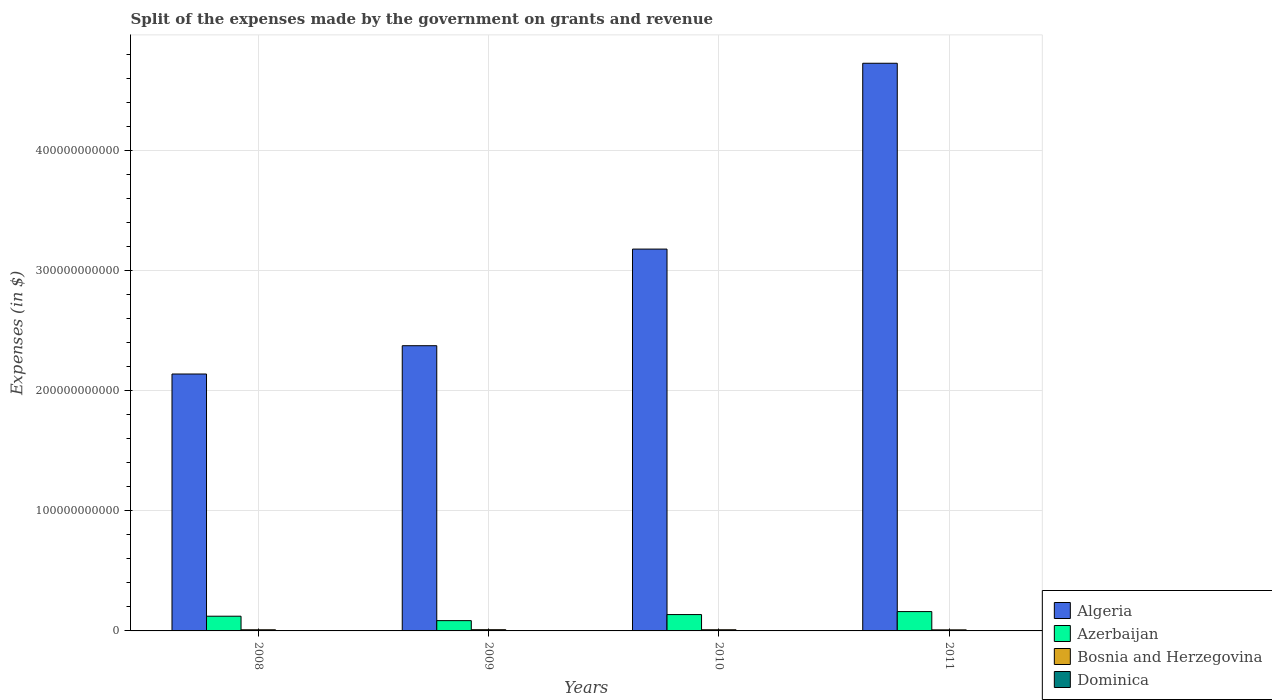How many different coloured bars are there?
Offer a terse response. 4. How many groups of bars are there?
Give a very brief answer. 4. Are the number of bars per tick equal to the number of legend labels?
Provide a short and direct response. Yes. Are the number of bars on each tick of the X-axis equal?
Offer a very short reply. Yes. In how many cases, is the number of bars for a given year not equal to the number of legend labels?
Provide a short and direct response. 0. What is the expenses made by the government on grants and revenue in Azerbaijan in 2010?
Ensure brevity in your answer.  1.36e+1. Across all years, what is the maximum expenses made by the government on grants and revenue in Bosnia and Herzegovina?
Your response must be concise. 1.02e+09. Across all years, what is the minimum expenses made by the government on grants and revenue in Azerbaijan?
Your answer should be very brief. 8.57e+09. What is the total expenses made by the government on grants and revenue in Algeria in the graph?
Keep it short and to the point. 1.24e+12. What is the difference between the expenses made by the government on grants and revenue in Azerbaijan in 2010 and that in 2011?
Your response must be concise. -2.48e+09. What is the difference between the expenses made by the government on grants and revenue in Algeria in 2008 and the expenses made by the government on grants and revenue in Azerbaijan in 2009?
Your answer should be very brief. 2.05e+11. What is the average expenses made by the government on grants and revenue in Bosnia and Herzegovina per year?
Give a very brief answer. 9.57e+08. In the year 2009, what is the difference between the expenses made by the government on grants and revenue in Algeria and expenses made by the government on grants and revenue in Azerbaijan?
Keep it short and to the point. 2.29e+11. What is the ratio of the expenses made by the government on grants and revenue in Azerbaijan in 2009 to that in 2010?
Your response must be concise. 0.63. Is the expenses made by the government on grants and revenue in Dominica in 2008 less than that in 2011?
Provide a short and direct response. No. What is the difference between the highest and the second highest expenses made by the government on grants and revenue in Dominica?
Your response must be concise. 1.74e+07. What is the difference between the highest and the lowest expenses made by the government on grants and revenue in Azerbaijan?
Offer a very short reply. 7.53e+09. Is the sum of the expenses made by the government on grants and revenue in Bosnia and Herzegovina in 2010 and 2011 greater than the maximum expenses made by the government on grants and revenue in Azerbaijan across all years?
Your answer should be compact. No. Is it the case that in every year, the sum of the expenses made by the government on grants and revenue in Dominica and expenses made by the government on grants and revenue in Azerbaijan is greater than the sum of expenses made by the government on grants and revenue in Algeria and expenses made by the government on grants and revenue in Bosnia and Herzegovina?
Provide a succinct answer. No. What does the 4th bar from the left in 2010 represents?
Provide a succinct answer. Dominica. What does the 4th bar from the right in 2010 represents?
Your answer should be compact. Algeria. Is it the case that in every year, the sum of the expenses made by the government on grants and revenue in Bosnia and Herzegovina and expenses made by the government on grants and revenue in Algeria is greater than the expenses made by the government on grants and revenue in Azerbaijan?
Your answer should be compact. Yes. What is the difference between two consecutive major ticks on the Y-axis?
Offer a terse response. 1.00e+11. Does the graph contain any zero values?
Provide a succinct answer. No. How many legend labels are there?
Your answer should be compact. 4. How are the legend labels stacked?
Keep it short and to the point. Vertical. What is the title of the graph?
Offer a terse response. Split of the expenses made by the government on grants and revenue. What is the label or title of the Y-axis?
Provide a succinct answer. Expenses (in $). What is the Expenses (in $) in Algeria in 2008?
Your answer should be compact. 2.14e+11. What is the Expenses (in $) in Azerbaijan in 2008?
Provide a succinct answer. 1.22e+1. What is the Expenses (in $) in Bosnia and Herzegovina in 2008?
Your answer should be very brief. 9.49e+08. What is the Expenses (in $) in Dominica in 2008?
Your response must be concise. 1.09e+08. What is the Expenses (in $) of Algeria in 2009?
Your answer should be compact. 2.37e+11. What is the Expenses (in $) in Azerbaijan in 2009?
Offer a very short reply. 8.57e+09. What is the Expenses (in $) of Bosnia and Herzegovina in 2009?
Offer a terse response. 1.02e+09. What is the Expenses (in $) of Dominica in 2009?
Give a very brief answer. 9.12e+07. What is the Expenses (in $) of Algeria in 2010?
Offer a very short reply. 3.18e+11. What is the Expenses (in $) in Azerbaijan in 2010?
Your answer should be very brief. 1.36e+1. What is the Expenses (in $) in Bosnia and Herzegovina in 2010?
Keep it short and to the point. 9.70e+08. What is the Expenses (in $) in Dominica in 2010?
Your answer should be very brief. 6.28e+07. What is the Expenses (in $) in Algeria in 2011?
Ensure brevity in your answer.  4.73e+11. What is the Expenses (in $) of Azerbaijan in 2011?
Provide a short and direct response. 1.61e+1. What is the Expenses (in $) in Bosnia and Herzegovina in 2011?
Your answer should be very brief. 8.87e+08. What is the Expenses (in $) of Dominica in 2011?
Make the answer very short. 7.71e+07. Across all years, what is the maximum Expenses (in $) in Algeria?
Give a very brief answer. 4.73e+11. Across all years, what is the maximum Expenses (in $) in Azerbaijan?
Your response must be concise. 1.61e+1. Across all years, what is the maximum Expenses (in $) in Bosnia and Herzegovina?
Offer a very short reply. 1.02e+09. Across all years, what is the maximum Expenses (in $) of Dominica?
Make the answer very short. 1.09e+08. Across all years, what is the minimum Expenses (in $) of Algeria?
Give a very brief answer. 2.14e+11. Across all years, what is the minimum Expenses (in $) of Azerbaijan?
Offer a very short reply. 8.57e+09. Across all years, what is the minimum Expenses (in $) of Bosnia and Herzegovina?
Ensure brevity in your answer.  8.87e+08. Across all years, what is the minimum Expenses (in $) in Dominica?
Offer a very short reply. 6.28e+07. What is the total Expenses (in $) of Algeria in the graph?
Offer a terse response. 1.24e+12. What is the total Expenses (in $) of Azerbaijan in the graph?
Keep it short and to the point. 5.05e+1. What is the total Expenses (in $) in Bosnia and Herzegovina in the graph?
Keep it short and to the point. 3.83e+09. What is the total Expenses (in $) in Dominica in the graph?
Provide a succinct answer. 3.40e+08. What is the difference between the Expenses (in $) of Algeria in 2008 and that in 2009?
Your response must be concise. -2.36e+1. What is the difference between the Expenses (in $) of Azerbaijan in 2008 and that in 2009?
Your answer should be compact. 3.67e+09. What is the difference between the Expenses (in $) in Bosnia and Herzegovina in 2008 and that in 2009?
Ensure brevity in your answer.  -7.27e+07. What is the difference between the Expenses (in $) in Dominica in 2008 and that in 2009?
Your response must be concise. 1.74e+07. What is the difference between the Expenses (in $) of Algeria in 2008 and that in 2010?
Make the answer very short. -1.04e+11. What is the difference between the Expenses (in $) in Azerbaijan in 2008 and that in 2010?
Provide a short and direct response. -1.37e+09. What is the difference between the Expenses (in $) in Bosnia and Herzegovina in 2008 and that in 2010?
Your answer should be very brief. -2.06e+07. What is the difference between the Expenses (in $) in Dominica in 2008 and that in 2010?
Give a very brief answer. 4.58e+07. What is the difference between the Expenses (in $) in Algeria in 2008 and that in 2011?
Provide a succinct answer. -2.59e+11. What is the difference between the Expenses (in $) in Azerbaijan in 2008 and that in 2011?
Make the answer very short. -3.86e+09. What is the difference between the Expenses (in $) in Bosnia and Herzegovina in 2008 and that in 2011?
Your answer should be compact. 6.24e+07. What is the difference between the Expenses (in $) of Dominica in 2008 and that in 2011?
Provide a succinct answer. 3.15e+07. What is the difference between the Expenses (in $) of Algeria in 2009 and that in 2010?
Ensure brevity in your answer.  -8.04e+1. What is the difference between the Expenses (in $) of Azerbaijan in 2009 and that in 2010?
Provide a short and direct response. -5.05e+09. What is the difference between the Expenses (in $) of Bosnia and Herzegovina in 2009 and that in 2010?
Give a very brief answer. 5.21e+07. What is the difference between the Expenses (in $) of Dominica in 2009 and that in 2010?
Offer a terse response. 2.84e+07. What is the difference between the Expenses (in $) in Algeria in 2009 and that in 2011?
Your response must be concise. -2.35e+11. What is the difference between the Expenses (in $) of Azerbaijan in 2009 and that in 2011?
Make the answer very short. -7.53e+09. What is the difference between the Expenses (in $) of Bosnia and Herzegovina in 2009 and that in 2011?
Ensure brevity in your answer.  1.35e+08. What is the difference between the Expenses (in $) in Dominica in 2009 and that in 2011?
Offer a terse response. 1.41e+07. What is the difference between the Expenses (in $) of Algeria in 2010 and that in 2011?
Offer a very short reply. -1.55e+11. What is the difference between the Expenses (in $) in Azerbaijan in 2010 and that in 2011?
Your answer should be very brief. -2.48e+09. What is the difference between the Expenses (in $) in Bosnia and Herzegovina in 2010 and that in 2011?
Ensure brevity in your answer.  8.30e+07. What is the difference between the Expenses (in $) of Dominica in 2010 and that in 2011?
Keep it short and to the point. -1.43e+07. What is the difference between the Expenses (in $) in Algeria in 2008 and the Expenses (in $) in Azerbaijan in 2009?
Give a very brief answer. 2.05e+11. What is the difference between the Expenses (in $) of Algeria in 2008 and the Expenses (in $) of Bosnia and Herzegovina in 2009?
Ensure brevity in your answer.  2.13e+11. What is the difference between the Expenses (in $) in Algeria in 2008 and the Expenses (in $) in Dominica in 2009?
Offer a very short reply. 2.14e+11. What is the difference between the Expenses (in $) in Azerbaijan in 2008 and the Expenses (in $) in Bosnia and Herzegovina in 2009?
Provide a short and direct response. 1.12e+1. What is the difference between the Expenses (in $) in Azerbaijan in 2008 and the Expenses (in $) in Dominica in 2009?
Your response must be concise. 1.22e+1. What is the difference between the Expenses (in $) of Bosnia and Herzegovina in 2008 and the Expenses (in $) of Dominica in 2009?
Offer a very short reply. 8.58e+08. What is the difference between the Expenses (in $) of Algeria in 2008 and the Expenses (in $) of Azerbaijan in 2010?
Provide a short and direct response. 2.00e+11. What is the difference between the Expenses (in $) in Algeria in 2008 and the Expenses (in $) in Bosnia and Herzegovina in 2010?
Provide a succinct answer. 2.13e+11. What is the difference between the Expenses (in $) in Algeria in 2008 and the Expenses (in $) in Dominica in 2010?
Give a very brief answer. 2.14e+11. What is the difference between the Expenses (in $) in Azerbaijan in 2008 and the Expenses (in $) in Bosnia and Herzegovina in 2010?
Your response must be concise. 1.13e+1. What is the difference between the Expenses (in $) of Azerbaijan in 2008 and the Expenses (in $) of Dominica in 2010?
Give a very brief answer. 1.22e+1. What is the difference between the Expenses (in $) in Bosnia and Herzegovina in 2008 and the Expenses (in $) in Dominica in 2010?
Provide a short and direct response. 8.87e+08. What is the difference between the Expenses (in $) in Algeria in 2008 and the Expenses (in $) in Azerbaijan in 2011?
Offer a very short reply. 1.98e+11. What is the difference between the Expenses (in $) of Algeria in 2008 and the Expenses (in $) of Bosnia and Herzegovina in 2011?
Your answer should be compact. 2.13e+11. What is the difference between the Expenses (in $) of Algeria in 2008 and the Expenses (in $) of Dominica in 2011?
Offer a very short reply. 2.14e+11. What is the difference between the Expenses (in $) of Azerbaijan in 2008 and the Expenses (in $) of Bosnia and Herzegovina in 2011?
Your response must be concise. 1.14e+1. What is the difference between the Expenses (in $) of Azerbaijan in 2008 and the Expenses (in $) of Dominica in 2011?
Provide a short and direct response. 1.22e+1. What is the difference between the Expenses (in $) of Bosnia and Herzegovina in 2008 and the Expenses (in $) of Dominica in 2011?
Offer a very short reply. 8.72e+08. What is the difference between the Expenses (in $) of Algeria in 2009 and the Expenses (in $) of Azerbaijan in 2010?
Your answer should be compact. 2.24e+11. What is the difference between the Expenses (in $) in Algeria in 2009 and the Expenses (in $) in Bosnia and Herzegovina in 2010?
Your answer should be compact. 2.36e+11. What is the difference between the Expenses (in $) of Algeria in 2009 and the Expenses (in $) of Dominica in 2010?
Keep it short and to the point. 2.37e+11. What is the difference between the Expenses (in $) of Azerbaijan in 2009 and the Expenses (in $) of Bosnia and Herzegovina in 2010?
Ensure brevity in your answer.  7.60e+09. What is the difference between the Expenses (in $) of Azerbaijan in 2009 and the Expenses (in $) of Dominica in 2010?
Keep it short and to the point. 8.50e+09. What is the difference between the Expenses (in $) of Bosnia and Herzegovina in 2009 and the Expenses (in $) of Dominica in 2010?
Your response must be concise. 9.59e+08. What is the difference between the Expenses (in $) in Algeria in 2009 and the Expenses (in $) in Azerbaijan in 2011?
Offer a very short reply. 2.21e+11. What is the difference between the Expenses (in $) in Algeria in 2009 and the Expenses (in $) in Bosnia and Herzegovina in 2011?
Your response must be concise. 2.37e+11. What is the difference between the Expenses (in $) in Algeria in 2009 and the Expenses (in $) in Dominica in 2011?
Offer a very short reply. 2.37e+11. What is the difference between the Expenses (in $) in Azerbaijan in 2009 and the Expenses (in $) in Bosnia and Herzegovina in 2011?
Your response must be concise. 7.68e+09. What is the difference between the Expenses (in $) in Azerbaijan in 2009 and the Expenses (in $) in Dominica in 2011?
Your response must be concise. 8.49e+09. What is the difference between the Expenses (in $) of Bosnia and Herzegovina in 2009 and the Expenses (in $) of Dominica in 2011?
Your answer should be very brief. 9.45e+08. What is the difference between the Expenses (in $) in Algeria in 2010 and the Expenses (in $) in Azerbaijan in 2011?
Keep it short and to the point. 3.02e+11. What is the difference between the Expenses (in $) of Algeria in 2010 and the Expenses (in $) of Bosnia and Herzegovina in 2011?
Ensure brevity in your answer.  3.17e+11. What is the difference between the Expenses (in $) in Algeria in 2010 and the Expenses (in $) in Dominica in 2011?
Provide a short and direct response. 3.18e+11. What is the difference between the Expenses (in $) in Azerbaijan in 2010 and the Expenses (in $) in Bosnia and Herzegovina in 2011?
Ensure brevity in your answer.  1.27e+1. What is the difference between the Expenses (in $) of Azerbaijan in 2010 and the Expenses (in $) of Dominica in 2011?
Offer a very short reply. 1.35e+1. What is the difference between the Expenses (in $) of Bosnia and Herzegovina in 2010 and the Expenses (in $) of Dominica in 2011?
Keep it short and to the point. 8.93e+08. What is the average Expenses (in $) in Algeria per year?
Provide a succinct answer. 3.10e+11. What is the average Expenses (in $) of Azerbaijan per year?
Make the answer very short. 1.26e+1. What is the average Expenses (in $) in Bosnia and Herzegovina per year?
Your answer should be very brief. 9.57e+08. What is the average Expenses (in $) in Dominica per year?
Give a very brief answer. 8.49e+07. In the year 2008, what is the difference between the Expenses (in $) of Algeria and Expenses (in $) of Azerbaijan?
Ensure brevity in your answer.  2.02e+11. In the year 2008, what is the difference between the Expenses (in $) of Algeria and Expenses (in $) of Bosnia and Herzegovina?
Give a very brief answer. 2.13e+11. In the year 2008, what is the difference between the Expenses (in $) in Algeria and Expenses (in $) in Dominica?
Offer a very short reply. 2.14e+11. In the year 2008, what is the difference between the Expenses (in $) in Azerbaijan and Expenses (in $) in Bosnia and Herzegovina?
Your response must be concise. 1.13e+1. In the year 2008, what is the difference between the Expenses (in $) in Azerbaijan and Expenses (in $) in Dominica?
Make the answer very short. 1.21e+1. In the year 2008, what is the difference between the Expenses (in $) of Bosnia and Herzegovina and Expenses (in $) of Dominica?
Your answer should be very brief. 8.41e+08. In the year 2009, what is the difference between the Expenses (in $) in Algeria and Expenses (in $) in Azerbaijan?
Your answer should be compact. 2.29e+11. In the year 2009, what is the difference between the Expenses (in $) in Algeria and Expenses (in $) in Bosnia and Herzegovina?
Ensure brevity in your answer.  2.36e+11. In the year 2009, what is the difference between the Expenses (in $) in Algeria and Expenses (in $) in Dominica?
Offer a very short reply. 2.37e+11. In the year 2009, what is the difference between the Expenses (in $) in Azerbaijan and Expenses (in $) in Bosnia and Herzegovina?
Your response must be concise. 7.55e+09. In the year 2009, what is the difference between the Expenses (in $) of Azerbaijan and Expenses (in $) of Dominica?
Provide a succinct answer. 8.48e+09. In the year 2009, what is the difference between the Expenses (in $) of Bosnia and Herzegovina and Expenses (in $) of Dominica?
Give a very brief answer. 9.31e+08. In the year 2010, what is the difference between the Expenses (in $) in Algeria and Expenses (in $) in Azerbaijan?
Your response must be concise. 3.04e+11. In the year 2010, what is the difference between the Expenses (in $) in Algeria and Expenses (in $) in Bosnia and Herzegovina?
Provide a succinct answer. 3.17e+11. In the year 2010, what is the difference between the Expenses (in $) of Algeria and Expenses (in $) of Dominica?
Keep it short and to the point. 3.18e+11. In the year 2010, what is the difference between the Expenses (in $) in Azerbaijan and Expenses (in $) in Bosnia and Herzegovina?
Offer a terse response. 1.26e+1. In the year 2010, what is the difference between the Expenses (in $) of Azerbaijan and Expenses (in $) of Dominica?
Make the answer very short. 1.36e+1. In the year 2010, what is the difference between the Expenses (in $) of Bosnia and Herzegovina and Expenses (in $) of Dominica?
Keep it short and to the point. 9.07e+08. In the year 2011, what is the difference between the Expenses (in $) of Algeria and Expenses (in $) of Azerbaijan?
Offer a terse response. 4.57e+11. In the year 2011, what is the difference between the Expenses (in $) in Algeria and Expenses (in $) in Bosnia and Herzegovina?
Your response must be concise. 4.72e+11. In the year 2011, what is the difference between the Expenses (in $) of Algeria and Expenses (in $) of Dominica?
Offer a very short reply. 4.73e+11. In the year 2011, what is the difference between the Expenses (in $) in Azerbaijan and Expenses (in $) in Bosnia and Herzegovina?
Offer a terse response. 1.52e+1. In the year 2011, what is the difference between the Expenses (in $) in Azerbaijan and Expenses (in $) in Dominica?
Your answer should be very brief. 1.60e+1. In the year 2011, what is the difference between the Expenses (in $) in Bosnia and Herzegovina and Expenses (in $) in Dominica?
Offer a terse response. 8.10e+08. What is the ratio of the Expenses (in $) of Algeria in 2008 to that in 2009?
Keep it short and to the point. 0.9. What is the ratio of the Expenses (in $) of Azerbaijan in 2008 to that in 2009?
Provide a short and direct response. 1.43. What is the ratio of the Expenses (in $) of Bosnia and Herzegovina in 2008 to that in 2009?
Your response must be concise. 0.93. What is the ratio of the Expenses (in $) of Dominica in 2008 to that in 2009?
Keep it short and to the point. 1.19. What is the ratio of the Expenses (in $) in Algeria in 2008 to that in 2010?
Give a very brief answer. 0.67. What is the ratio of the Expenses (in $) of Azerbaijan in 2008 to that in 2010?
Provide a short and direct response. 0.9. What is the ratio of the Expenses (in $) in Bosnia and Herzegovina in 2008 to that in 2010?
Make the answer very short. 0.98. What is the ratio of the Expenses (in $) of Dominica in 2008 to that in 2010?
Make the answer very short. 1.73. What is the ratio of the Expenses (in $) of Algeria in 2008 to that in 2011?
Keep it short and to the point. 0.45. What is the ratio of the Expenses (in $) of Azerbaijan in 2008 to that in 2011?
Ensure brevity in your answer.  0.76. What is the ratio of the Expenses (in $) of Bosnia and Herzegovina in 2008 to that in 2011?
Ensure brevity in your answer.  1.07. What is the ratio of the Expenses (in $) of Dominica in 2008 to that in 2011?
Offer a terse response. 1.41. What is the ratio of the Expenses (in $) of Algeria in 2009 to that in 2010?
Provide a succinct answer. 0.75. What is the ratio of the Expenses (in $) in Azerbaijan in 2009 to that in 2010?
Provide a succinct answer. 0.63. What is the ratio of the Expenses (in $) of Bosnia and Herzegovina in 2009 to that in 2010?
Keep it short and to the point. 1.05. What is the ratio of the Expenses (in $) of Dominica in 2009 to that in 2010?
Provide a short and direct response. 1.45. What is the ratio of the Expenses (in $) in Algeria in 2009 to that in 2011?
Your answer should be compact. 0.5. What is the ratio of the Expenses (in $) of Azerbaijan in 2009 to that in 2011?
Ensure brevity in your answer.  0.53. What is the ratio of the Expenses (in $) in Bosnia and Herzegovina in 2009 to that in 2011?
Offer a very short reply. 1.15. What is the ratio of the Expenses (in $) in Dominica in 2009 to that in 2011?
Offer a terse response. 1.18. What is the ratio of the Expenses (in $) in Algeria in 2010 to that in 2011?
Your answer should be compact. 0.67. What is the ratio of the Expenses (in $) in Azerbaijan in 2010 to that in 2011?
Your response must be concise. 0.85. What is the ratio of the Expenses (in $) in Bosnia and Herzegovina in 2010 to that in 2011?
Provide a short and direct response. 1.09. What is the ratio of the Expenses (in $) in Dominica in 2010 to that in 2011?
Ensure brevity in your answer.  0.81. What is the difference between the highest and the second highest Expenses (in $) in Algeria?
Give a very brief answer. 1.55e+11. What is the difference between the highest and the second highest Expenses (in $) in Azerbaijan?
Provide a succinct answer. 2.48e+09. What is the difference between the highest and the second highest Expenses (in $) in Bosnia and Herzegovina?
Give a very brief answer. 5.21e+07. What is the difference between the highest and the second highest Expenses (in $) in Dominica?
Make the answer very short. 1.74e+07. What is the difference between the highest and the lowest Expenses (in $) in Algeria?
Provide a succinct answer. 2.59e+11. What is the difference between the highest and the lowest Expenses (in $) in Azerbaijan?
Give a very brief answer. 7.53e+09. What is the difference between the highest and the lowest Expenses (in $) in Bosnia and Herzegovina?
Provide a short and direct response. 1.35e+08. What is the difference between the highest and the lowest Expenses (in $) in Dominica?
Give a very brief answer. 4.58e+07. 